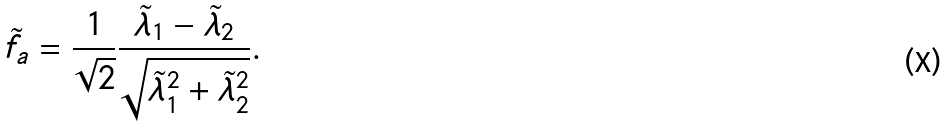<formula> <loc_0><loc_0><loc_500><loc_500>\tilde { f } _ { a } = \frac { 1 } { \sqrt { 2 } } \frac { \tilde { \lambda } _ { 1 } - \tilde { \lambda } _ { 2 } } { \sqrt { \tilde { \lambda } _ { 1 } ^ { 2 } + \tilde { \lambda } _ { 2 } ^ { 2 } } } .</formula> 